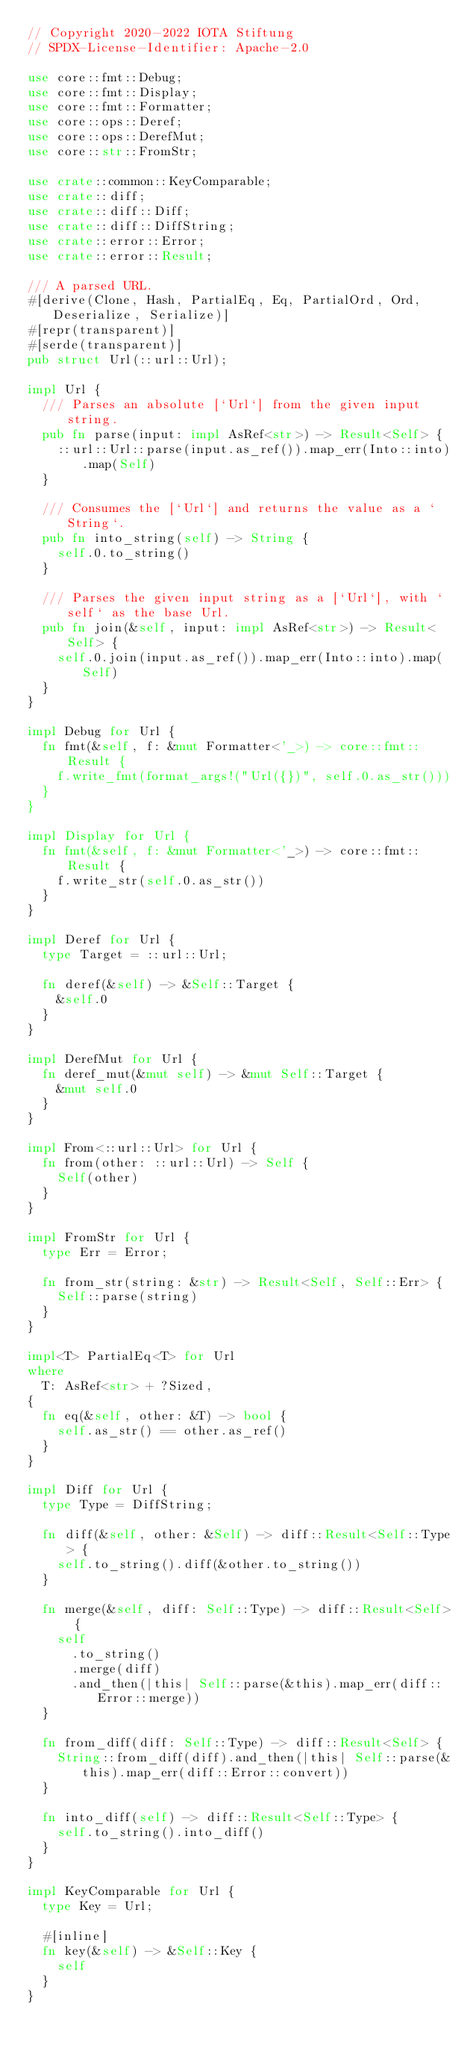<code> <loc_0><loc_0><loc_500><loc_500><_Rust_>// Copyright 2020-2022 IOTA Stiftung
// SPDX-License-Identifier: Apache-2.0

use core::fmt::Debug;
use core::fmt::Display;
use core::fmt::Formatter;
use core::ops::Deref;
use core::ops::DerefMut;
use core::str::FromStr;

use crate::common::KeyComparable;
use crate::diff;
use crate::diff::Diff;
use crate::diff::DiffString;
use crate::error::Error;
use crate::error::Result;

/// A parsed URL.
#[derive(Clone, Hash, PartialEq, Eq, PartialOrd, Ord, Deserialize, Serialize)]
#[repr(transparent)]
#[serde(transparent)]
pub struct Url(::url::Url);

impl Url {
  /// Parses an absolute [`Url`] from the given input string.
  pub fn parse(input: impl AsRef<str>) -> Result<Self> {
    ::url::Url::parse(input.as_ref()).map_err(Into::into).map(Self)
  }

  /// Consumes the [`Url`] and returns the value as a `String`.
  pub fn into_string(self) -> String {
    self.0.to_string()
  }

  /// Parses the given input string as a [`Url`], with `self` as the base Url.
  pub fn join(&self, input: impl AsRef<str>) -> Result<Self> {
    self.0.join(input.as_ref()).map_err(Into::into).map(Self)
  }
}

impl Debug for Url {
  fn fmt(&self, f: &mut Formatter<'_>) -> core::fmt::Result {
    f.write_fmt(format_args!("Url({})", self.0.as_str()))
  }
}

impl Display for Url {
  fn fmt(&self, f: &mut Formatter<'_>) -> core::fmt::Result {
    f.write_str(self.0.as_str())
  }
}

impl Deref for Url {
  type Target = ::url::Url;

  fn deref(&self) -> &Self::Target {
    &self.0
  }
}

impl DerefMut for Url {
  fn deref_mut(&mut self) -> &mut Self::Target {
    &mut self.0
  }
}

impl From<::url::Url> for Url {
  fn from(other: ::url::Url) -> Self {
    Self(other)
  }
}

impl FromStr for Url {
  type Err = Error;

  fn from_str(string: &str) -> Result<Self, Self::Err> {
    Self::parse(string)
  }
}

impl<T> PartialEq<T> for Url
where
  T: AsRef<str> + ?Sized,
{
  fn eq(&self, other: &T) -> bool {
    self.as_str() == other.as_ref()
  }
}

impl Diff for Url {
  type Type = DiffString;

  fn diff(&self, other: &Self) -> diff::Result<Self::Type> {
    self.to_string().diff(&other.to_string())
  }

  fn merge(&self, diff: Self::Type) -> diff::Result<Self> {
    self
      .to_string()
      .merge(diff)
      .and_then(|this| Self::parse(&this).map_err(diff::Error::merge))
  }

  fn from_diff(diff: Self::Type) -> diff::Result<Self> {
    String::from_diff(diff).and_then(|this| Self::parse(&this).map_err(diff::Error::convert))
  }

  fn into_diff(self) -> diff::Result<Self::Type> {
    self.to_string().into_diff()
  }
}

impl KeyComparable for Url {
  type Key = Url;

  #[inline]
  fn key(&self) -> &Self::Key {
    self
  }
}
</code> 